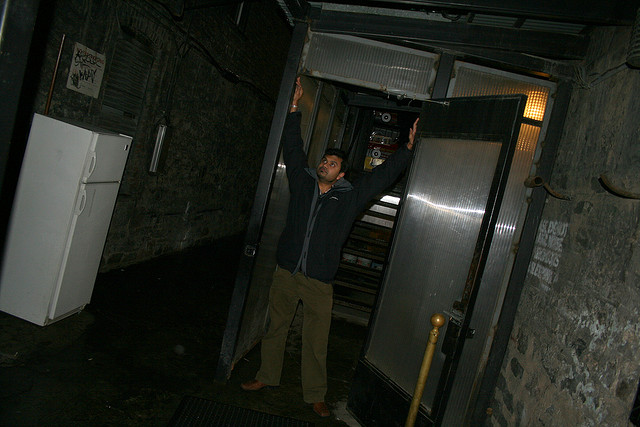<image>Which item casts a shadow on the wall? It is ambiguous which item casts a shadow on the wall. It could be a door, TV, person or refrigerator. Which item casts a shadow on the wall? I am not sure which item casts a shadow on the wall. It can be seen the door, TV, person, man, or refrigerator. 